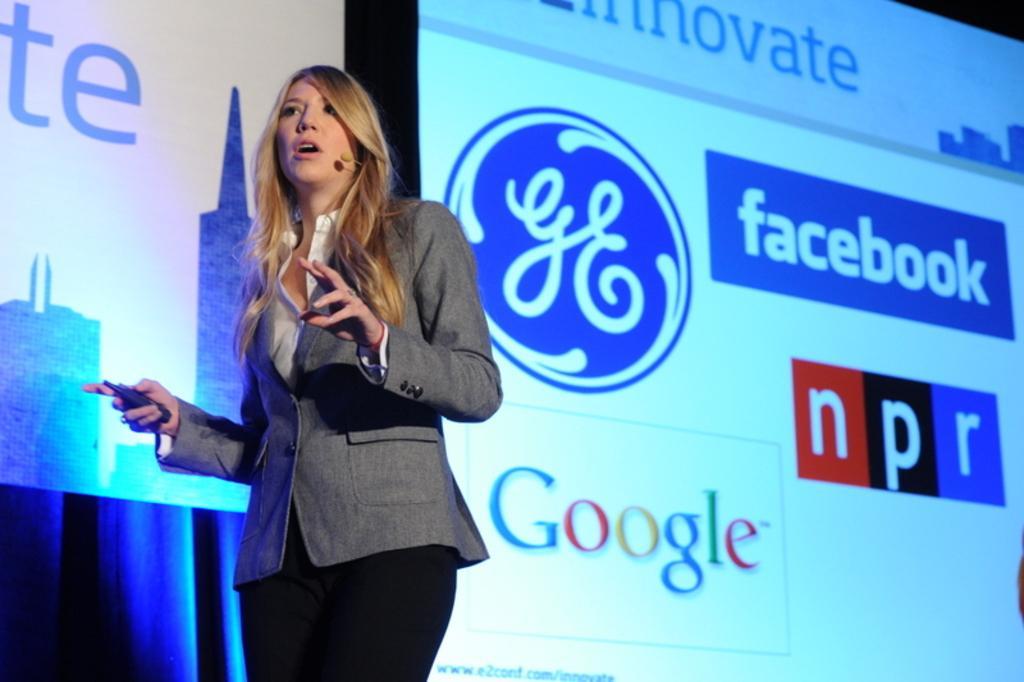Describe this image in one or two sentences. In this image on the left side there is one woman who is standing and she is holding something, and she is talking and in the background there are screens. And on the screen there is text, and there is a curtain. 